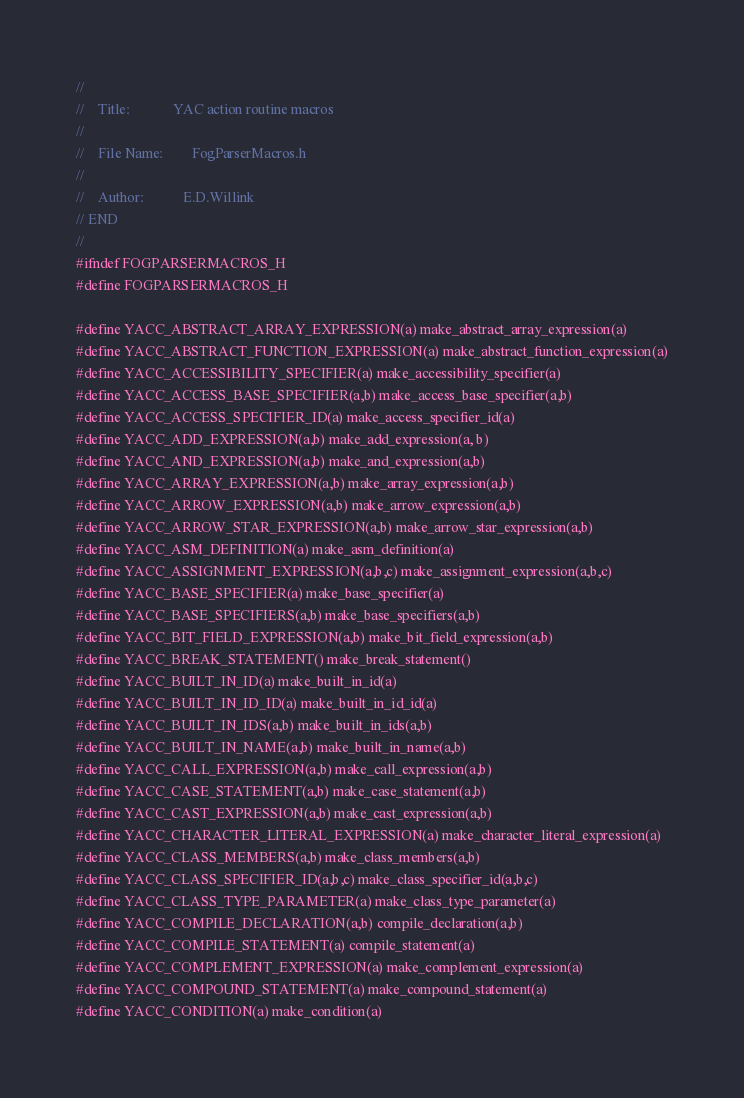Convert code to text. <code><loc_0><loc_0><loc_500><loc_500><_C_>// 
// 	  Title:			YAC action routine macros
// 
// 	  File Name:		FogParserMacros.h
// 
// 	  Author:			E.D.Willink
// END
// 
#ifndef FOGPARSERMACROS_H
#define FOGPARSERMACROS_H

#define YACC_ABSTRACT_ARRAY_EXPRESSION(a) make_abstract_array_expression(a)
#define YACC_ABSTRACT_FUNCTION_EXPRESSION(a) make_abstract_function_expression(a)
#define YACC_ACCESSIBILITY_SPECIFIER(a) make_accessibility_specifier(a)
#define YACC_ACCESS_BASE_SPECIFIER(a,b) make_access_base_specifier(a,b)
#define YACC_ACCESS_SPECIFIER_ID(a) make_access_specifier_id(a)
#define YACC_ADD_EXPRESSION(a,b) make_add_expression(a, b)
#define YACC_AND_EXPRESSION(a,b) make_and_expression(a,b)
#define YACC_ARRAY_EXPRESSION(a,b) make_array_expression(a,b)
#define YACC_ARROW_EXPRESSION(a,b) make_arrow_expression(a,b)
#define YACC_ARROW_STAR_EXPRESSION(a,b) make_arrow_star_expression(a,b)
#define YACC_ASM_DEFINITION(a) make_asm_definition(a)
#define YACC_ASSIGNMENT_EXPRESSION(a,b,c) make_assignment_expression(a,b,c)
#define YACC_BASE_SPECIFIER(a) make_base_specifier(a)
#define YACC_BASE_SPECIFIERS(a,b) make_base_specifiers(a,b)
#define YACC_BIT_FIELD_EXPRESSION(a,b) make_bit_field_expression(a,b)
#define YACC_BREAK_STATEMENT() make_break_statement()
#define YACC_BUILT_IN_ID(a) make_built_in_id(a)
#define YACC_BUILT_IN_ID_ID(a) make_built_in_id_id(a)
#define YACC_BUILT_IN_IDS(a,b) make_built_in_ids(a,b)
#define YACC_BUILT_IN_NAME(a,b) make_built_in_name(a,b)
#define YACC_CALL_EXPRESSION(a,b) make_call_expression(a,b)
#define YACC_CASE_STATEMENT(a,b) make_case_statement(a,b)
#define YACC_CAST_EXPRESSION(a,b) make_cast_expression(a,b)
#define YACC_CHARACTER_LITERAL_EXPRESSION(a) make_character_literal_expression(a)
#define YACC_CLASS_MEMBERS(a,b) make_class_members(a,b)
#define YACC_CLASS_SPECIFIER_ID(a,b,c) make_class_specifier_id(a,b,c)
#define YACC_CLASS_TYPE_PARAMETER(a) make_class_type_parameter(a)
#define YACC_COMPILE_DECLARATION(a,b) compile_declaration(a,b)
#define YACC_COMPILE_STATEMENT(a) compile_statement(a)
#define YACC_COMPLEMENT_EXPRESSION(a) make_complement_expression(a)
#define YACC_COMPOUND_STATEMENT(a) make_compound_statement(a)
#define YACC_CONDITION(a) make_condition(a)</code> 